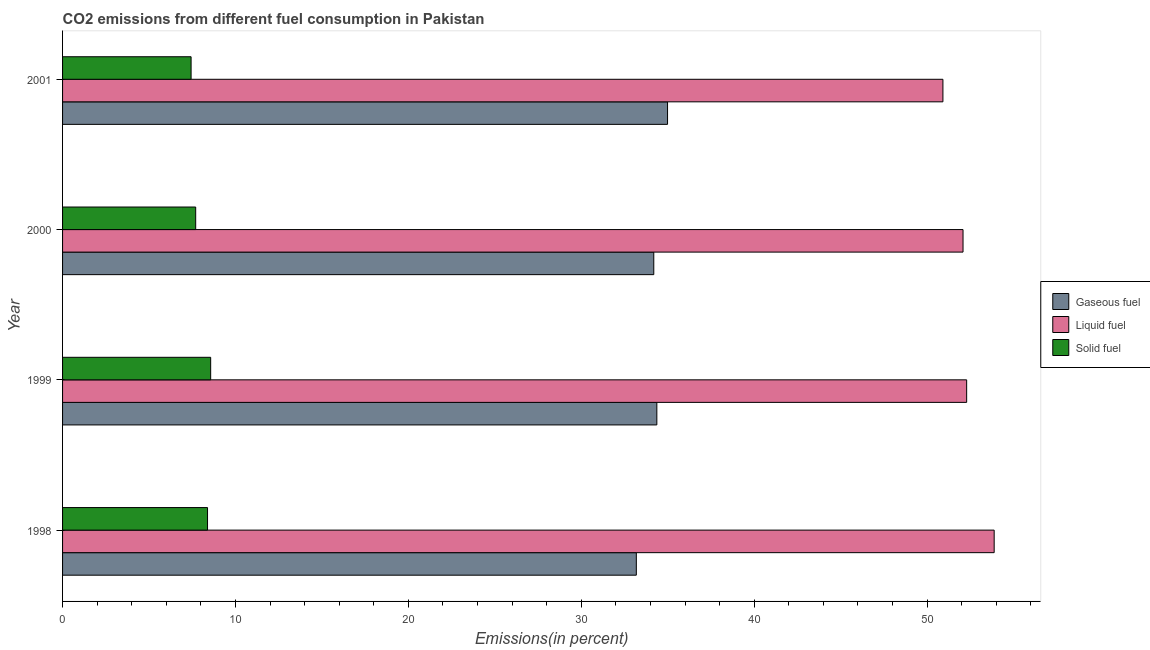How many groups of bars are there?
Your answer should be compact. 4. Are the number of bars on each tick of the Y-axis equal?
Your response must be concise. Yes. How many bars are there on the 4th tick from the top?
Your answer should be compact. 3. What is the percentage of solid fuel emission in 2000?
Your answer should be compact. 7.7. Across all years, what is the maximum percentage of gaseous fuel emission?
Give a very brief answer. 34.99. Across all years, what is the minimum percentage of liquid fuel emission?
Your answer should be very brief. 50.92. In which year was the percentage of gaseous fuel emission maximum?
Your answer should be very brief. 2001. In which year was the percentage of solid fuel emission minimum?
Offer a terse response. 2001. What is the total percentage of solid fuel emission in the graph?
Your answer should be very brief. 32.08. What is the difference between the percentage of solid fuel emission in 1999 and that in 2001?
Keep it short and to the point. 1.13. What is the difference between the percentage of liquid fuel emission in 1998 and the percentage of gaseous fuel emission in 1999?
Your answer should be very brief. 19.51. What is the average percentage of gaseous fuel emission per year?
Make the answer very short. 34.18. In the year 1998, what is the difference between the percentage of solid fuel emission and percentage of gaseous fuel emission?
Your answer should be very brief. -24.8. In how many years, is the percentage of gaseous fuel emission greater than 8 %?
Provide a succinct answer. 4. What is the ratio of the percentage of liquid fuel emission in 1999 to that in 2001?
Provide a succinct answer. 1.03. Is the percentage of gaseous fuel emission in 1998 less than that in 1999?
Provide a succinct answer. Yes. Is the difference between the percentage of gaseous fuel emission in 1998 and 2000 greater than the difference between the percentage of liquid fuel emission in 1998 and 2000?
Your answer should be very brief. No. What is the difference between the highest and the second highest percentage of liquid fuel emission?
Your response must be concise. 1.59. What is the difference between the highest and the lowest percentage of solid fuel emission?
Provide a succinct answer. 1.13. What does the 3rd bar from the top in 2000 represents?
Ensure brevity in your answer.  Gaseous fuel. What does the 3rd bar from the bottom in 1999 represents?
Make the answer very short. Solid fuel. Are the values on the major ticks of X-axis written in scientific E-notation?
Offer a terse response. No. Does the graph contain any zero values?
Make the answer very short. No. How many legend labels are there?
Offer a very short reply. 3. What is the title of the graph?
Offer a very short reply. CO2 emissions from different fuel consumption in Pakistan. What is the label or title of the X-axis?
Provide a succinct answer. Emissions(in percent). What is the label or title of the Y-axis?
Offer a terse response. Year. What is the Emissions(in percent) in Gaseous fuel in 1998?
Your answer should be very brief. 33.18. What is the Emissions(in percent) of Liquid fuel in 1998?
Offer a terse response. 53.88. What is the Emissions(in percent) in Solid fuel in 1998?
Your answer should be compact. 8.38. What is the Emissions(in percent) in Gaseous fuel in 1999?
Provide a succinct answer. 34.37. What is the Emissions(in percent) of Liquid fuel in 1999?
Keep it short and to the point. 52.29. What is the Emissions(in percent) in Solid fuel in 1999?
Your answer should be very brief. 8.57. What is the Emissions(in percent) of Gaseous fuel in 2000?
Give a very brief answer. 34.19. What is the Emissions(in percent) of Liquid fuel in 2000?
Provide a succinct answer. 52.08. What is the Emissions(in percent) in Solid fuel in 2000?
Offer a terse response. 7.7. What is the Emissions(in percent) of Gaseous fuel in 2001?
Offer a very short reply. 34.99. What is the Emissions(in percent) of Liquid fuel in 2001?
Ensure brevity in your answer.  50.92. What is the Emissions(in percent) in Solid fuel in 2001?
Make the answer very short. 7.43. Across all years, what is the maximum Emissions(in percent) of Gaseous fuel?
Make the answer very short. 34.99. Across all years, what is the maximum Emissions(in percent) in Liquid fuel?
Ensure brevity in your answer.  53.88. Across all years, what is the maximum Emissions(in percent) in Solid fuel?
Offer a very short reply. 8.57. Across all years, what is the minimum Emissions(in percent) in Gaseous fuel?
Keep it short and to the point. 33.18. Across all years, what is the minimum Emissions(in percent) of Liquid fuel?
Make the answer very short. 50.92. Across all years, what is the minimum Emissions(in percent) of Solid fuel?
Give a very brief answer. 7.43. What is the total Emissions(in percent) in Gaseous fuel in the graph?
Provide a short and direct response. 136.74. What is the total Emissions(in percent) of Liquid fuel in the graph?
Offer a very short reply. 209.16. What is the total Emissions(in percent) in Solid fuel in the graph?
Make the answer very short. 32.08. What is the difference between the Emissions(in percent) of Gaseous fuel in 1998 and that in 1999?
Your answer should be compact. -1.19. What is the difference between the Emissions(in percent) in Liquid fuel in 1998 and that in 1999?
Your response must be concise. 1.59. What is the difference between the Emissions(in percent) in Solid fuel in 1998 and that in 1999?
Provide a short and direct response. -0.18. What is the difference between the Emissions(in percent) in Gaseous fuel in 1998 and that in 2000?
Offer a terse response. -1.01. What is the difference between the Emissions(in percent) of Liquid fuel in 1998 and that in 2000?
Offer a terse response. 1.8. What is the difference between the Emissions(in percent) of Solid fuel in 1998 and that in 2000?
Give a very brief answer. 0.69. What is the difference between the Emissions(in percent) in Gaseous fuel in 1998 and that in 2001?
Your answer should be compact. -1.8. What is the difference between the Emissions(in percent) in Liquid fuel in 1998 and that in 2001?
Offer a terse response. 2.96. What is the difference between the Emissions(in percent) in Solid fuel in 1998 and that in 2001?
Ensure brevity in your answer.  0.95. What is the difference between the Emissions(in percent) in Gaseous fuel in 1999 and that in 2000?
Provide a short and direct response. 0.18. What is the difference between the Emissions(in percent) of Liquid fuel in 1999 and that in 2000?
Your response must be concise. 0.21. What is the difference between the Emissions(in percent) of Solid fuel in 1999 and that in 2000?
Your response must be concise. 0.87. What is the difference between the Emissions(in percent) in Gaseous fuel in 1999 and that in 2001?
Provide a succinct answer. -0.62. What is the difference between the Emissions(in percent) of Liquid fuel in 1999 and that in 2001?
Ensure brevity in your answer.  1.37. What is the difference between the Emissions(in percent) in Solid fuel in 1999 and that in 2001?
Keep it short and to the point. 1.13. What is the difference between the Emissions(in percent) of Gaseous fuel in 2000 and that in 2001?
Offer a terse response. -0.8. What is the difference between the Emissions(in percent) in Liquid fuel in 2000 and that in 2001?
Offer a terse response. 1.16. What is the difference between the Emissions(in percent) in Solid fuel in 2000 and that in 2001?
Provide a short and direct response. 0.27. What is the difference between the Emissions(in percent) in Gaseous fuel in 1998 and the Emissions(in percent) in Liquid fuel in 1999?
Your answer should be very brief. -19.1. What is the difference between the Emissions(in percent) in Gaseous fuel in 1998 and the Emissions(in percent) in Solid fuel in 1999?
Ensure brevity in your answer.  24.62. What is the difference between the Emissions(in percent) in Liquid fuel in 1998 and the Emissions(in percent) in Solid fuel in 1999?
Make the answer very short. 45.31. What is the difference between the Emissions(in percent) in Gaseous fuel in 1998 and the Emissions(in percent) in Liquid fuel in 2000?
Make the answer very short. -18.89. What is the difference between the Emissions(in percent) in Gaseous fuel in 1998 and the Emissions(in percent) in Solid fuel in 2000?
Provide a short and direct response. 25.49. What is the difference between the Emissions(in percent) in Liquid fuel in 1998 and the Emissions(in percent) in Solid fuel in 2000?
Offer a terse response. 46.18. What is the difference between the Emissions(in percent) of Gaseous fuel in 1998 and the Emissions(in percent) of Liquid fuel in 2001?
Your response must be concise. -17.73. What is the difference between the Emissions(in percent) in Gaseous fuel in 1998 and the Emissions(in percent) in Solid fuel in 2001?
Give a very brief answer. 25.75. What is the difference between the Emissions(in percent) of Liquid fuel in 1998 and the Emissions(in percent) of Solid fuel in 2001?
Your response must be concise. 46.45. What is the difference between the Emissions(in percent) in Gaseous fuel in 1999 and the Emissions(in percent) in Liquid fuel in 2000?
Provide a succinct answer. -17.71. What is the difference between the Emissions(in percent) in Gaseous fuel in 1999 and the Emissions(in percent) in Solid fuel in 2000?
Give a very brief answer. 26.67. What is the difference between the Emissions(in percent) in Liquid fuel in 1999 and the Emissions(in percent) in Solid fuel in 2000?
Make the answer very short. 44.59. What is the difference between the Emissions(in percent) of Gaseous fuel in 1999 and the Emissions(in percent) of Liquid fuel in 2001?
Your answer should be very brief. -16.55. What is the difference between the Emissions(in percent) of Gaseous fuel in 1999 and the Emissions(in percent) of Solid fuel in 2001?
Your answer should be compact. 26.94. What is the difference between the Emissions(in percent) in Liquid fuel in 1999 and the Emissions(in percent) in Solid fuel in 2001?
Your answer should be compact. 44.86. What is the difference between the Emissions(in percent) of Gaseous fuel in 2000 and the Emissions(in percent) of Liquid fuel in 2001?
Provide a short and direct response. -16.72. What is the difference between the Emissions(in percent) of Gaseous fuel in 2000 and the Emissions(in percent) of Solid fuel in 2001?
Your answer should be very brief. 26.76. What is the difference between the Emissions(in percent) of Liquid fuel in 2000 and the Emissions(in percent) of Solid fuel in 2001?
Give a very brief answer. 44.65. What is the average Emissions(in percent) of Gaseous fuel per year?
Offer a very short reply. 34.18. What is the average Emissions(in percent) of Liquid fuel per year?
Provide a short and direct response. 52.29. What is the average Emissions(in percent) of Solid fuel per year?
Give a very brief answer. 8.02. In the year 1998, what is the difference between the Emissions(in percent) of Gaseous fuel and Emissions(in percent) of Liquid fuel?
Your answer should be compact. -20.7. In the year 1998, what is the difference between the Emissions(in percent) in Gaseous fuel and Emissions(in percent) in Solid fuel?
Offer a terse response. 24.8. In the year 1998, what is the difference between the Emissions(in percent) of Liquid fuel and Emissions(in percent) of Solid fuel?
Provide a succinct answer. 45.5. In the year 1999, what is the difference between the Emissions(in percent) in Gaseous fuel and Emissions(in percent) in Liquid fuel?
Give a very brief answer. -17.92. In the year 1999, what is the difference between the Emissions(in percent) of Gaseous fuel and Emissions(in percent) of Solid fuel?
Your response must be concise. 25.8. In the year 1999, what is the difference between the Emissions(in percent) in Liquid fuel and Emissions(in percent) in Solid fuel?
Your response must be concise. 43.72. In the year 2000, what is the difference between the Emissions(in percent) in Gaseous fuel and Emissions(in percent) in Liquid fuel?
Keep it short and to the point. -17.89. In the year 2000, what is the difference between the Emissions(in percent) in Gaseous fuel and Emissions(in percent) in Solid fuel?
Offer a terse response. 26.49. In the year 2000, what is the difference between the Emissions(in percent) in Liquid fuel and Emissions(in percent) in Solid fuel?
Your answer should be compact. 44.38. In the year 2001, what is the difference between the Emissions(in percent) of Gaseous fuel and Emissions(in percent) of Liquid fuel?
Keep it short and to the point. -15.93. In the year 2001, what is the difference between the Emissions(in percent) in Gaseous fuel and Emissions(in percent) in Solid fuel?
Provide a short and direct response. 27.56. In the year 2001, what is the difference between the Emissions(in percent) in Liquid fuel and Emissions(in percent) in Solid fuel?
Offer a very short reply. 43.48. What is the ratio of the Emissions(in percent) of Gaseous fuel in 1998 to that in 1999?
Ensure brevity in your answer.  0.97. What is the ratio of the Emissions(in percent) of Liquid fuel in 1998 to that in 1999?
Make the answer very short. 1.03. What is the ratio of the Emissions(in percent) of Solid fuel in 1998 to that in 1999?
Give a very brief answer. 0.98. What is the ratio of the Emissions(in percent) in Gaseous fuel in 1998 to that in 2000?
Provide a short and direct response. 0.97. What is the ratio of the Emissions(in percent) of Liquid fuel in 1998 to that in 2000?
Your answer should be compact. 1.03. What is the ratio of the Emissions(in percent) of Solid fuel in 1998 to that in 2000?
Provide a short and direct response. 1.09. What is the ratio of the Emissions(in percent) of Gaseous fuel in 1998 to that in 2001?
Offer a very short reply. 0.95. What is the ratio of the Emissions(in percent) in Liquid fuel in 1998 to that in 2001?
Your answer should be very brief. 1.06. What is the ratio of the Emissions(in percent) of Solid fuel in 1998 to that in 2001?
Offer a very short reply. 1.13. What is the ratio of the Emissions(in percent) in Liquid fuel in 1999 to that in 2000?
Provide a short and direct response. 1. What is the ratio of the Emissions(in percent) in Solid fuel in 1999 to that in 2000?
Keep it short and to the point. 1.11. What is the ratio of the Emissions(in percent) of Gaseous fuel in 1999 to that in 2001?
Give a very brief answer. 0.98. What is the ratio of the Emissions(in percent) in Liquid fuel in 1999 to that in 2001?
Provide a succinct answer. 1.03. What is the ratio of the Emissions(in percent) in Solid fuel in 1999 to that in 2001?
Your answer should be compact. 1.15. What is the ratio of the Emissions(in percent) in Gaseous fuel in 2000 to that in 2001?
Your response must be concise. 0.98. What is the ratio of the Emissions(in percent) in Liquid fuel in 2000 to that in 2001?
Make the answer very short. 1.02. What is the ratio of the Emissions(in percent) in Solid fuel in 2000 to that in 2001?
Provide a short and direct response. 1.04. What is the difference between the highest and the second highest Emissions(in percent) in Gaseous fuel?
Offer a terse response. 0.62. What is the difference between the highest and the second highest Emissions(in percent) in Liquid fuel?
Ensure brevity in your answer.  1.59. What is the difference between the highest and the second highest Emissions(in percent) in Solid fuel?
Provide a succinct answer. 0.18. What is the difference between the highest and the lowest Emissions(in percent) of Gaseous fuel?
Your answer should be very brief. 1.8. What is the difference between the highest and the lowest Emissions(in percent) in Liquid fuel?
Ensure brevity in your answer.  2.96. What is the difference between the highest and the lowest Emissions(in percent) of Solid fuel?
Your answer should be very brief. 1.13. 